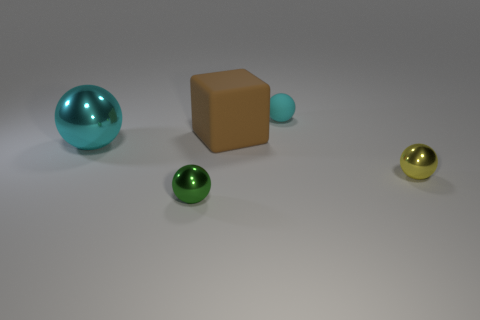Can you describe the lighting in the scene? The lighting in the scene is soft and uniform, producing gentle shadows beneath each object. This indicates a diffuse light source above and possibly slight ambient light in the environment. 